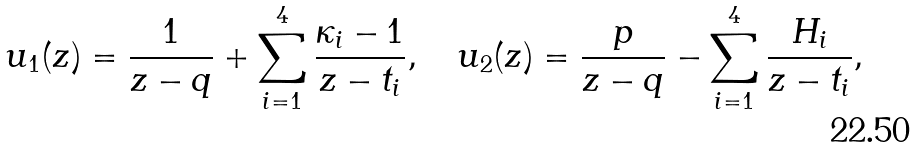<formula> <loc_0><loc_0><loc_500><loc_500>u _ { 1 } ( z ) = \frac { 1 } { z - q } + \sum _ { i = 1 } ^ { 4 } \frac { \kappa _ { i } - 1 } { z - t _ { i } } , \quad u _ { 2 } ( z ) = \frac { p } { z - q } - \sum _ { i = 1 } ^ { 4 } \frac { H _ { i } } { z - t _ { i } } ,</formula> 